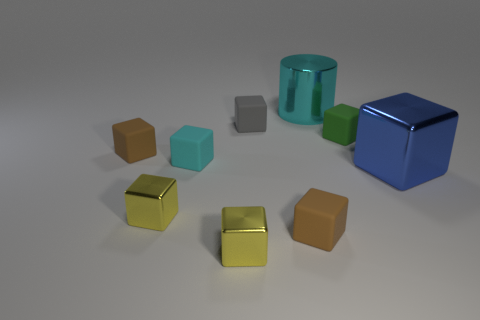Subtract all large blue metal blocks. How many blocks are left? 7 Add 1 green matte things. How many objects exist? 10 Subtract 8 blocks. How many blocks are left? 0 Subtract all gray blocks. How many blocks are left? 7 Subtract all cubes. How many objects are left? 1 Add 9 cyan matte blocks. How many cyan matte blocks exist? 10 Subtract 1 blue cubes. How many objects are left? 8 Subtract all brown blocks. Subtract all purple balls. How many blocks are left? 6 Subtract all blue spheres. How many brown cubes are left? 2 Subtract all tiny yellow shiny blocks. Subtract all brown cubes. How many objects are left? 5 